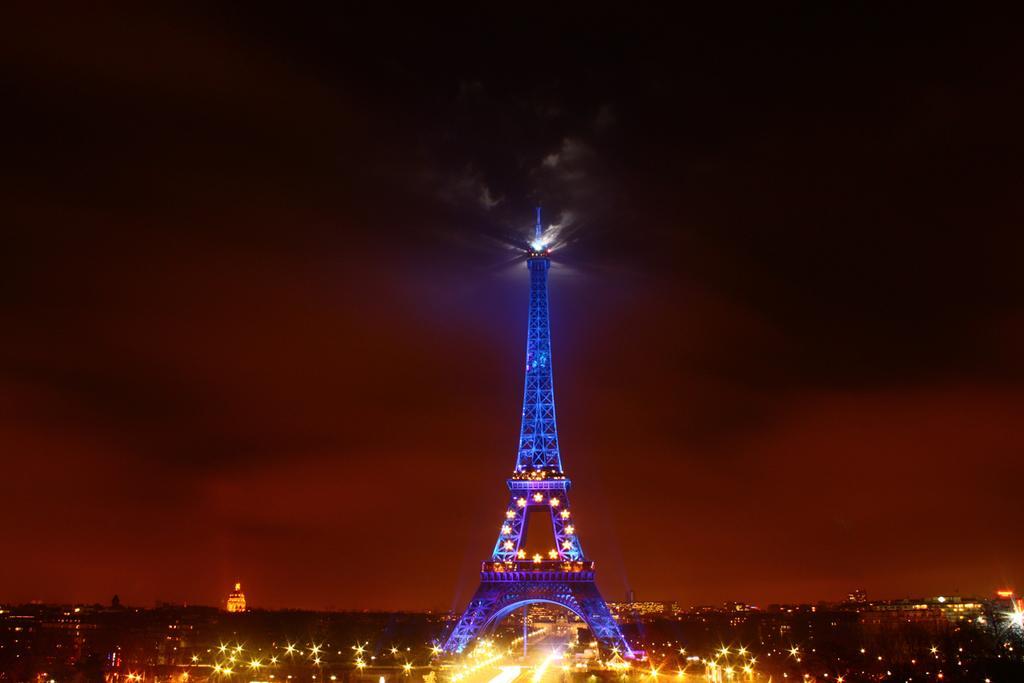In one or two sentences, can you explain what this image depicts? In this image I can see the Eiffel Tower and number of lights. I can also see this image is little bit in dark. 